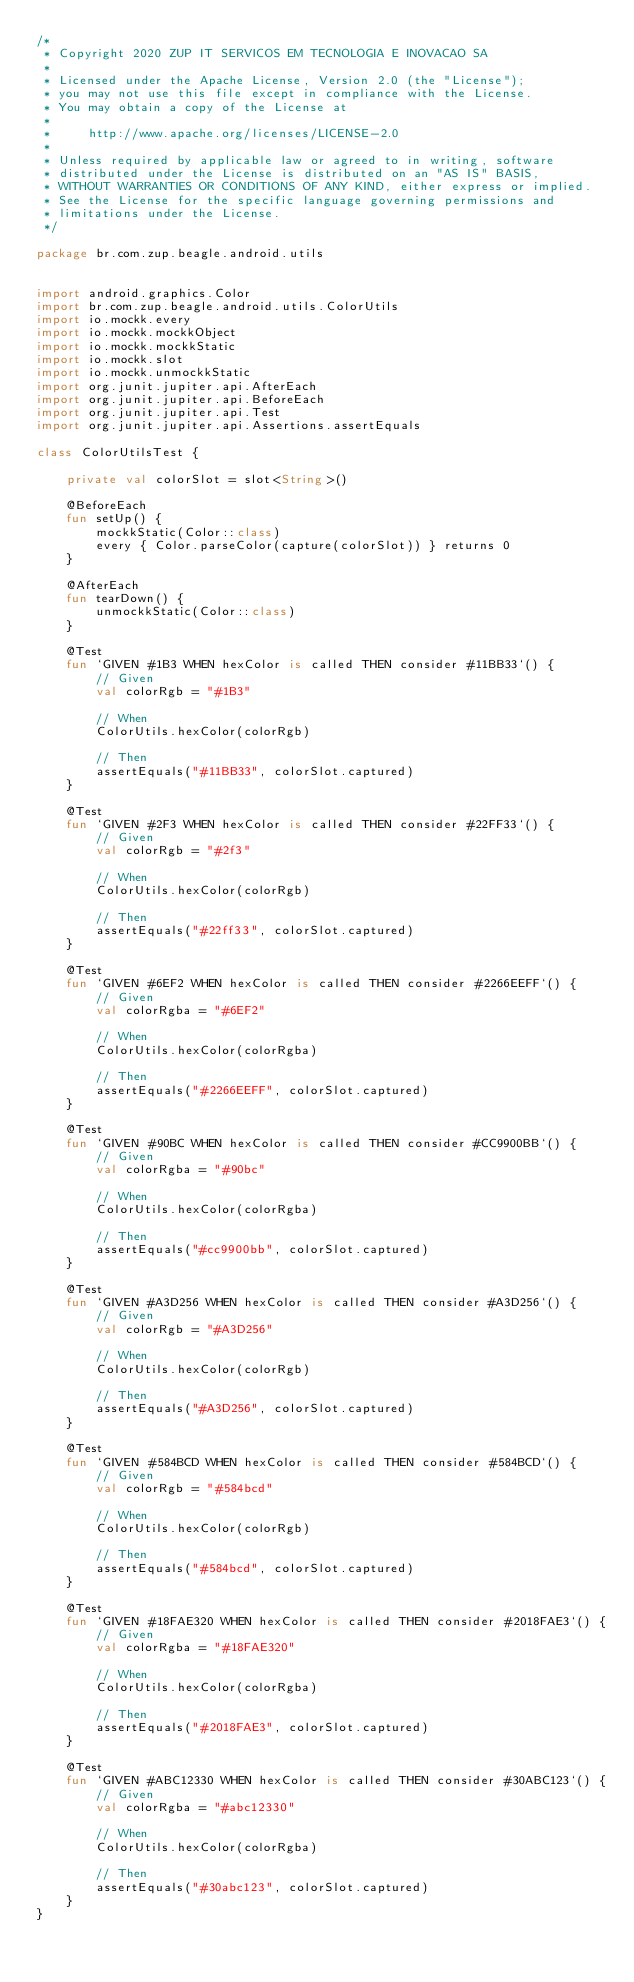Convert code to text. <code><loc_0><loc_0><loc_500><loc_500><_Kotlin_>/*
 * Copyright 2020 ZUP IT SERVICOS EM TECNOLOGIA E INOVACAO SA
 *
 * Licensed under the Apache License, Version 2.0 (the "License");
 * you may not use this file except in compliance with the License.
 * You may obtain a copy of the License at
 *
 *     http://www.apache.org/licenses/LICENSE-2.0
 *
 * Unless required by applicable law or agreed to in writing, software
 * distributed under the License is distributed on an "AS IS" BASIS,
 * WITHOUT WARRANTIES OR CONDITIONS OF ANY KIND, either express or implied.
 * See the License for the specific language governing permissions and
 * limitations under the License.
 */

package br.com.zup.beagle.android.utils


import android.graphics.Color
import br.com.zup.beagle.android.utils.ColorUtils
import io.mockk.every
import io.mockk.mockkObject
import io.mockk.mockkStatic
import io.mockk.slot
import io.mockk.unmockkStatic
import org.junit.jupiter.api.AfterEach
import org.junit.jupiter.api.BeforeEach
import org.junit.jupiter.api.Test
import org.junit.jupiter.api.Assertions.assertEquals

class ColorUtilsTest {

    private val colorSlot = slot<String>()

    @BeforeEach
    fun setUp() {
        mockkStatic(Color::class)
        every { Color.parseColor(capture(colorSlot)) } returns 0
    }

    @AfterEach
    fun tearDown() {
        unmockkStatic(Color::class)
    }

    @Test
    fun `GIVEN #1B3 WHEN hexColor is called THEN consider #11BB33`() {
        // Given
        val colorRgb = "#1B3"

        // When
        ColorUtils.hexColor(colorRgb)

        // Then
        assertEquals("#11BB33", colorSlot.captured)
    }

    @Test
    fun `GIVEN #2F3 WHEN hexColor is called THEN consider #22FF33`() {
        // Given
        val colorRgb = "#2f3"

        // When
        ColorUtils.hexColor(colorRgb)

        // Then
        assertEquals("#22ff33", colorSlot.captured)
    }

    @Test
    fun `GIVEN #6EF2 WHEN hexColor is called THEN consider #2266EEFF`() {
        // Given
        val colorRgba = "#6EF2"

        // When
        ColorUtils.hexColor(colorRgba)

        // Then
        assertEquals("#2266EEFF", colorSlot.captured)
    }

    @Test
    fun `GIVEN #90BC WHEN hexColor is called THEN consider #CC9900BB`() {
        // Given
        val colorRgba = "#90bc"

        // When
        ColorUtils.hexColor(colorRgba)

        // Then
        assertEquals("#cc9900bb", colorSlot.captured)
    }

    @Test
    fun `GIVEN #A3D256 WHEN hexColor is called THEN consider #A3D256`() {
        // Given
        val colorRgb = "#A3D256"

        // When
        ColorUtils.hexColor(colorRgb)

        // Then
        assertEquals("#A3D256", colorSlot.captured)
    }

    @Test
    fun `GIVEN #584BCD WHEN hexColor is called THEN consider #584BCD`() {
        // Given
        val colorRgb = "#584bcd"

        // When
        ColorUtils.hexColor(colorRgb)

        // Then
        assertEquals("#584bcd", colorSlot.captured)
    }

    @Test
    fun `GIVEN #18FAE320 WHEN hexColor is called THEN consider #2018FAE3`() {
        // Given
        val colorRgba = "#18FAE320"

        // When
        ColorUtils.hexColor(colorRgba)

        // Then
        assertEquals("#2018FAE3", colorSlot.captured)
    }

    @Test
    fun `GIVEN #ABC12330 WHEN hexColor is called THEN consider #30ABC123`() {
        // Given
        val colorRgba = "#abc12330"

        // When
        ColorUtils.hexColor(colorRgba)

        // Then
        assertEquals("#30abc123", colorSlot.captured)
    }
}
</code> 